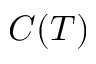<formula> <loc_0><loc_0><loc_500><loc_500>C ( T )</formula> 